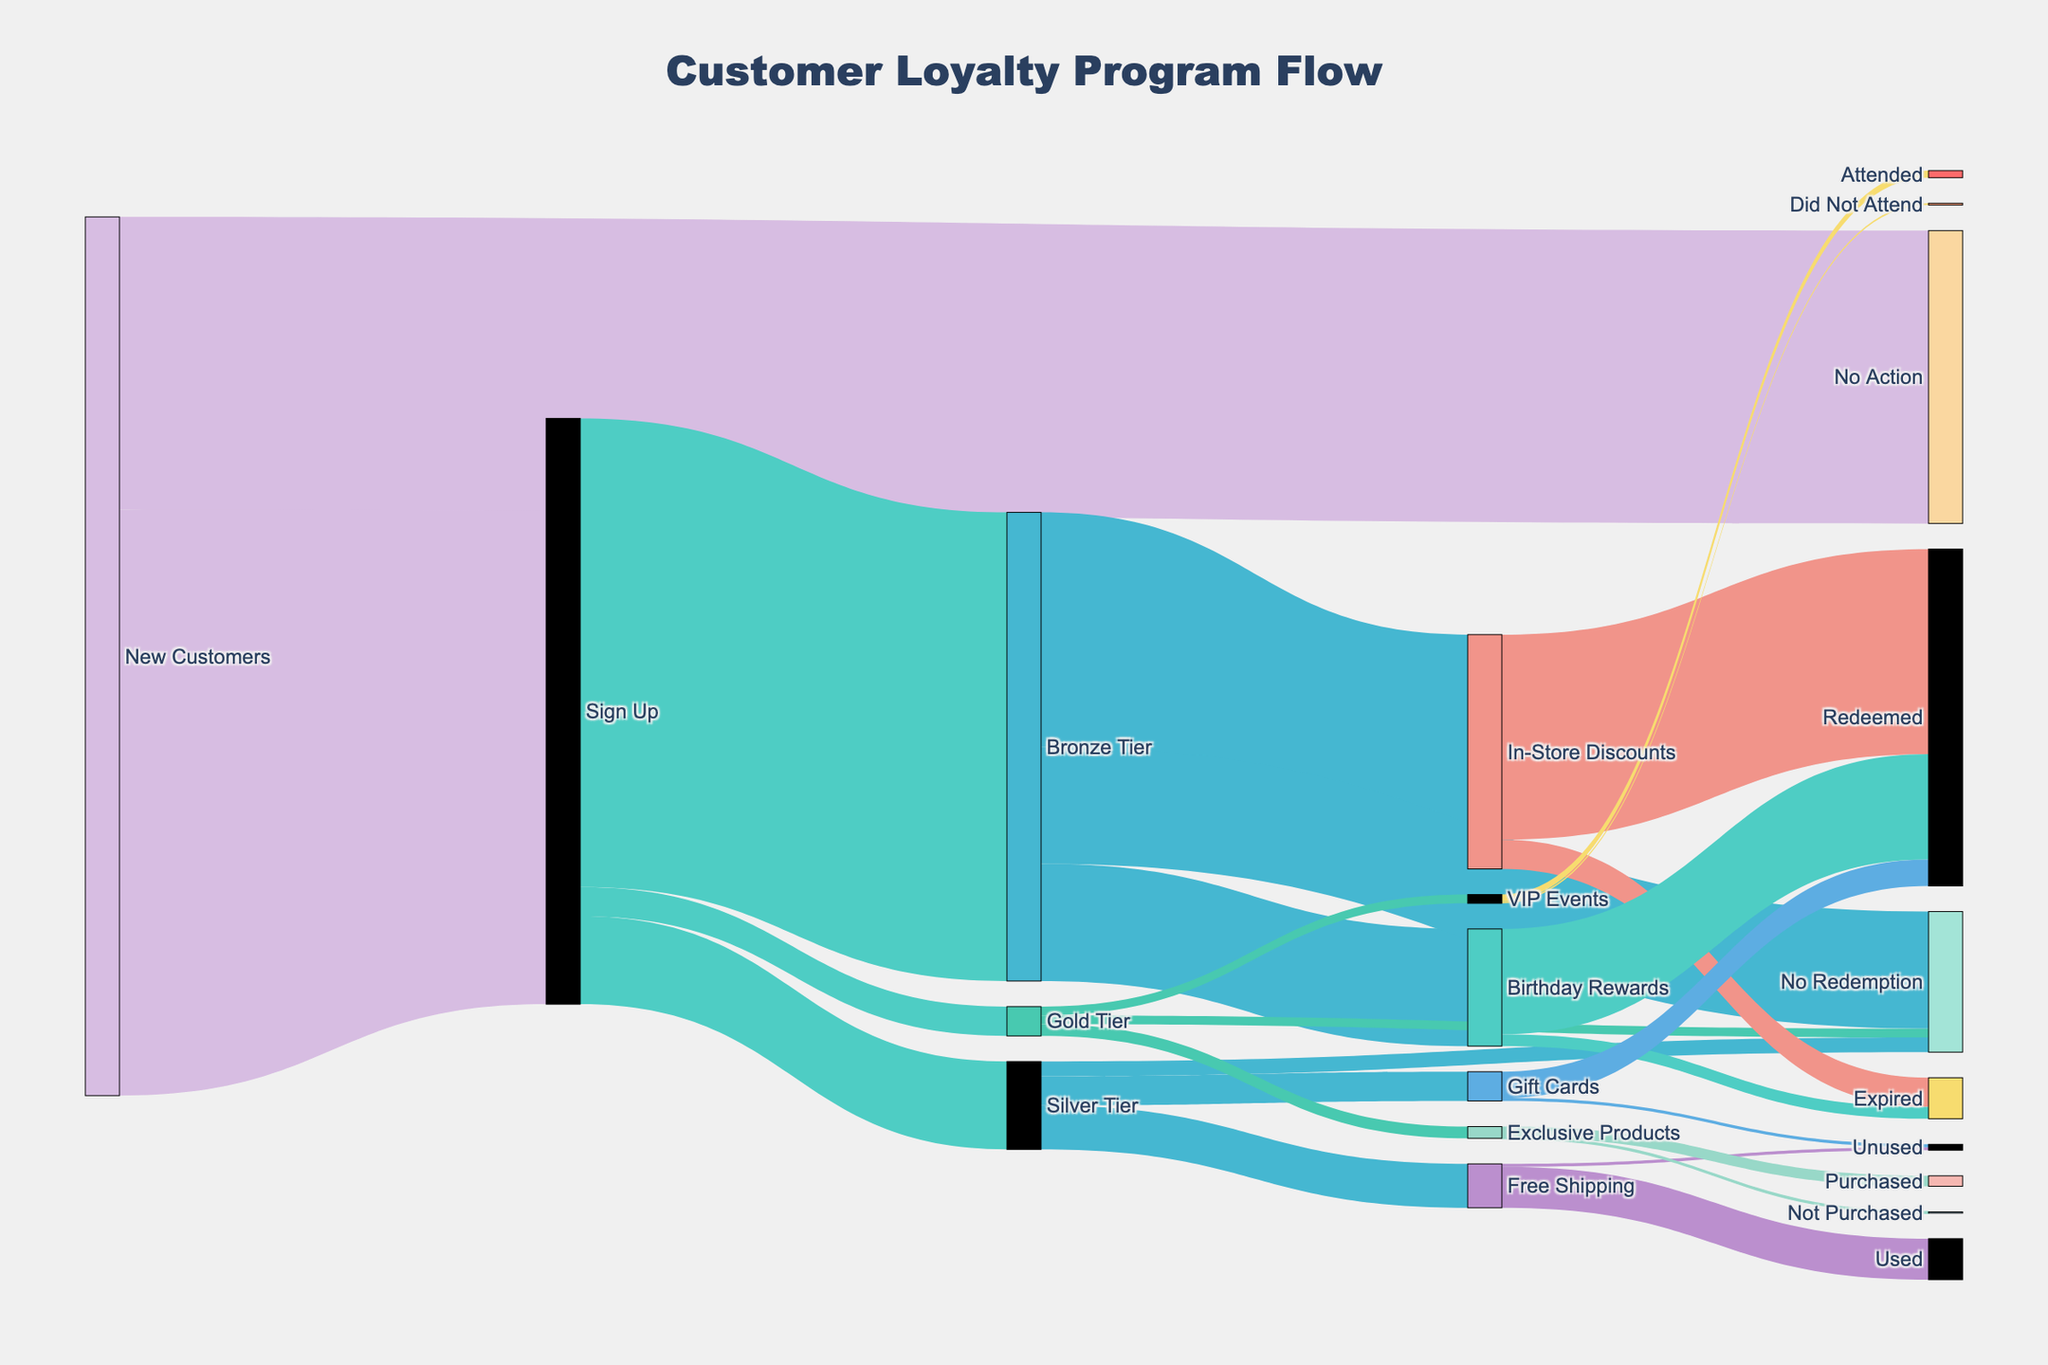Which group has the most participants signing up? First, identify where the participants sign up. The node "Sign Up" has incoming connections only from "New Customers" with a value of 1,000.
Answer: Sign Up Which reward tier has the highest number of participants? Start from the "Sign Up" node and follow its connections to "Bronze Tier," "Silver Tier," and "Gold Tier." The values are 800, 150, and 50, respectively.
Answer: Bronze Tier How many new customers take no action? Locate the flow from "New Customers" to "No Action" and note its value, which is 500.
Answer: 500 What is the total number of participants who did not redeem their rewards in any tier? Sum up the values for "No Redemption" in Bronze Tier, Silver Tier, and Gold Tier. These values are 200, 25, and 15 respectively.
Answer: 240 How many bronze tier participants redeemed in-store discounts? Look at the flow from "Bronze Tier" to "In-Store Discounts" and then from "In-Store Discounts" to "Redeemed," which gives a value of 350.
Answer: 350 How many gold tier participants attended VIP events? Follow the path from "Gold Tier" to "VIP Events" and then "VIP Events" to "Attended," which has a value of 12.
Answer: 12 Compare the number of participants in Silver Tier and Gold Tier. Which one is greater, and by how much? Silver Tier has 150 participants, while Gold Tier has 50. Subtract 50 from 150.
Answer: Silver Tier by 100 Which reward category in the Silver Tier has the least usage? Identify the nodes under Silver Tier: "Free Shipping" (75), "Gift Cards" (50), and "No Redemption" (25). "No Redemption" has the smallest value.
Answer: No Redemption Add up all the participants who redeemed their birthday rewards. Look at the "Birthday Rewards" node and find the flow to "Redeemed," which is 180.
Answer: 180 What percentage of in-store discounts went unused from the Bronze Tier? From the "In-Store Discounts," 50 out of 400 expired. Calculate (50/400) * 100.
Answer: 12.5% 